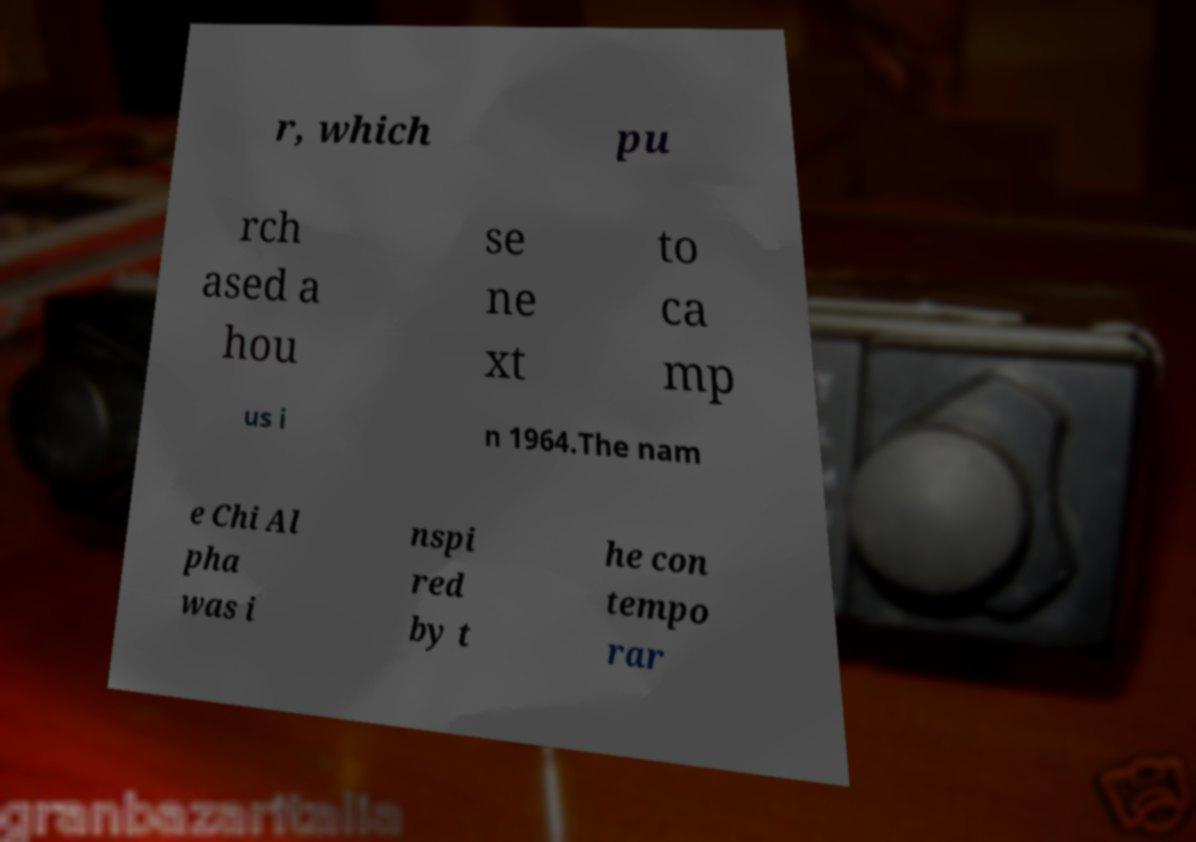Please identify and transcribe the text found in this image. r, which pu rch ased a hou se ne xt to ca mp us i n 1964.The nam e Chi Al pha was i nspi red by t he con tempo rar 